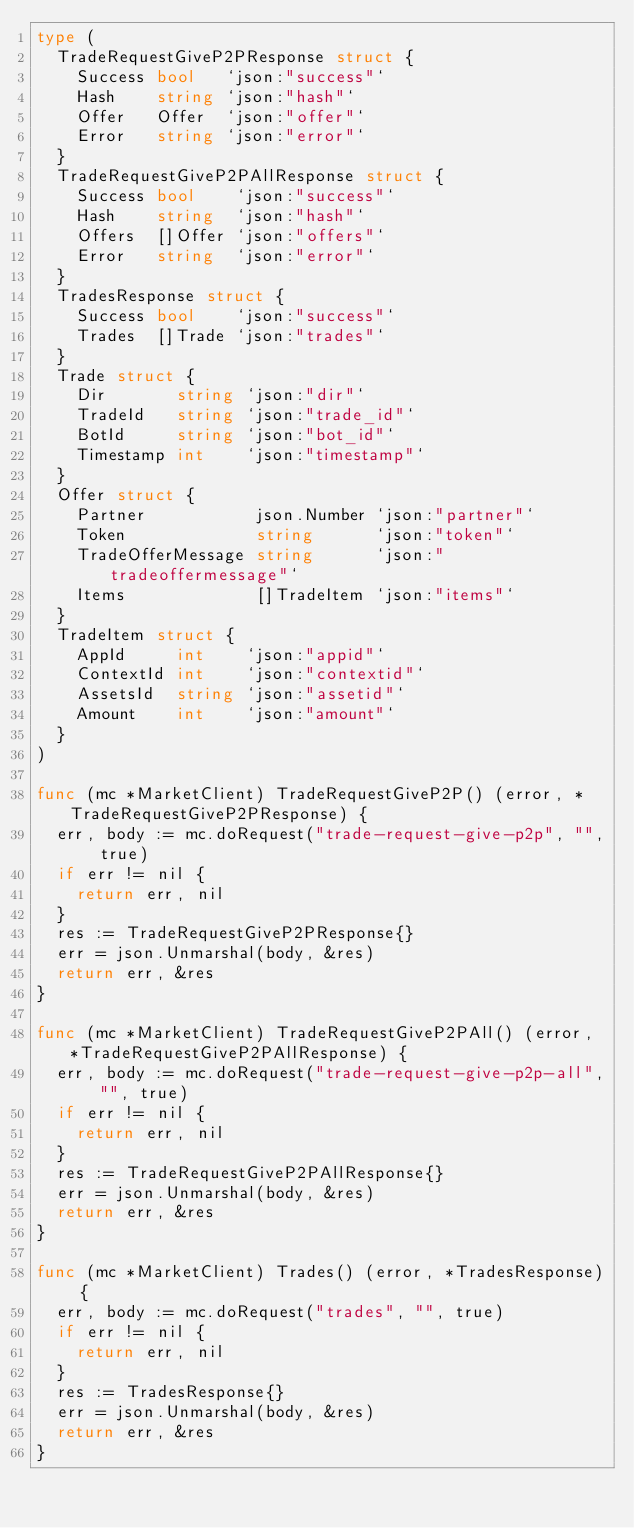<code> <loc_0><loc_0><loc_500><loc_500><_Go_>type (
	TradeRequestGiveP2PResponse struct {
		Success bool   `json:"success"`
		Hash    string `json:"hash"`
		Offer   Offer  `json:"offer"`
		Error   string `json:"error"`
	}
	TradeRequestGiveP2PAllResponse struct {
		Success bool    `json:"success"`
		Hash    string  `json:"hash"`
		Offers  []Offer `json:"offers"`
		Error   string  `json:"error"`
	}
	TradesResponse struct {
		Success bool    `json:"success"`
		Trades  []Trade `json:"trades"`
	}
	Trade struct {
		Dir       string `json:"dir"`
		TradeId   string `json:"trade_id"`
		BotId     string `json:"bot_id"`
		Timestamp int    `json:"timestamp"`
	}
	Offer struct {
		Partner           json.Number `json:"partner"`
		Token             string      `json:"token"`
		TradeOfferMessage string      `json:"tradeoffermessage"`
		Items             []TradeItem `json:"items"`
	}
	TradeItem struct {
		AppId     int    `json:"appid"`
		ContextId int    `json:"contextid"`
		AssetsId  string `json:"assetid"`
		Amount    int    `json:"amount"`
	}
)

func (mc *MarketClient) TradeRequestGiveP2P() (error, *TradeRequestGiveP2PResponse) {
	err, body := mc.doRequest("trade-request-give-p2p", "", true)
	if err != nil {
		return err, nil
	}
	res := TradeRequestGiveP2PResponse{}
	err = json.Unmarshal(body, &res)
	return err, &res
}

func (mc *MarketClient) TradeRequestGiveP2PAll() (error, *TradeRequestGiveP2PAllResponse) {
	err, body := mc.doRequest("trade-request-give-p2p-all", "", true)
	if err != nil {
		return err, nil
	}
	res := TradeRequestGiveP2PAllResponse{}
	err = json.Unmarshal(body, &res)
	return err, &res
}

func (mc *MarketClient) Trades() (error, *TradesResponse) {
	err, body := mc.doRequest("trades", "", true)
	if err != nil {
		return err, nil
	}
	res := TradesResponse{}
	err = json.Unmarshal(body, &res)
	return err, &res
}
</code> 